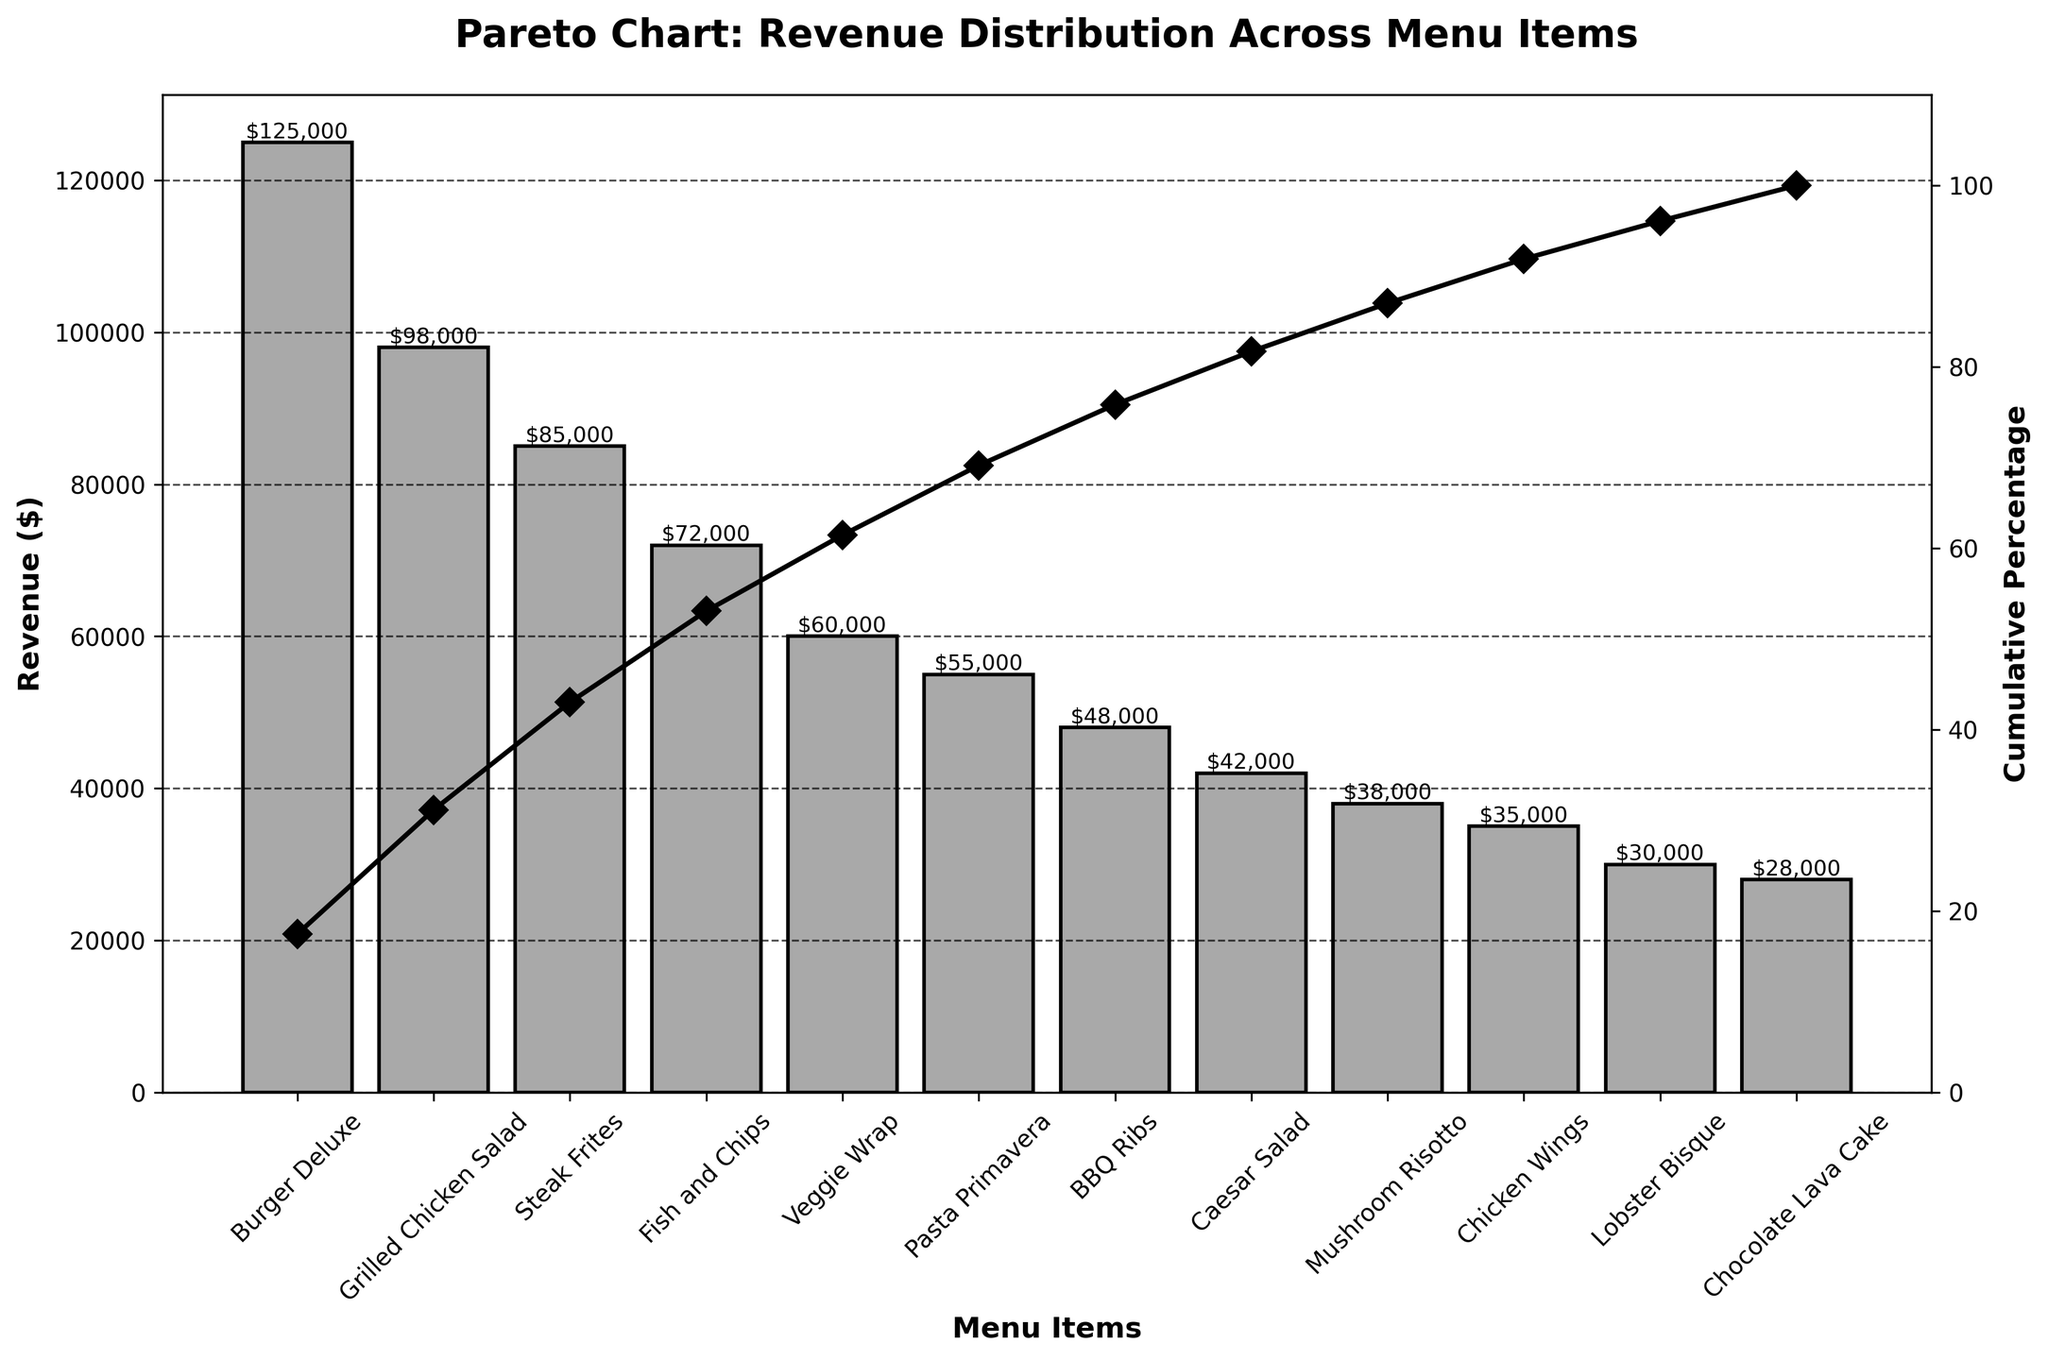Which menu item has the highest revenue? The bar representing the Burger Deluxe is the highest in the bar chart, indicating it generates the most revenue.
Answer: Burger Deluxe What is the total revenue of Burger Deluxe and Grilled Chicken Salad combined? The revenue for Burger Deluxe is $125,000, and for Grilled Chicken Salad, it is $98,000. Added together, they total $125,000 + $98,000 = $223,000.
Answer: $223,000 Which menu item is responsible for achieving the first 50% of cumulative revenue? By looking at the cumulative percentage line, we can see that Steak Frites helps achieve the first 50% of cumulative revenue, marking the halfway point on the graph.
Answer: Steak Frites What is the cumulative percentage after adding the revenue from Fish and Chips? The cumulative percentage after adding Fish and Chips is the sum of cumulative percentages of Burger Deluxe, Grilled Chicken Salad, Steak Frites, and Fish and Chips. This totals approximately 63%.
Answer: 63% How many menu items cumulatively contribute to at least 80% of the revenue? Starting from the highest revenue item to the lowest, we find the number of items contributing to 80% by following the cumulative percentage line. It reaches 80% around the sixth or seventh item. Hence, six menu items cumulatively contribute to at least 80%.
Answer: 6 Which generates more revenue: Veggie Wrap or Pasta Primavera? By comparing the heights of the bars for Veggie Wrap and Pasta Primavera, we can conclude that Veggie Wrap generates more revenue.
Answer: Veggie Wrap What is the approximate range of revenue values represented in the chart? The lowest revenue figure is that of Chocolate Lava Cake at $28,000, and the highest is Burger Deluxe at $125,000. Thus, the range is approximately $125,000 - $28,000 = $97,000.
Answer: $97,000 By how much does the revenue of BBQ Ribs differ from that of Caesar Salad? BBQ Ribs have a revenue of $48,000, and Caesar Salad has $42,000. The difference is $48,000 - $42,000 = $6,000.
Answer: $6,000 What percentage of revenue does the combination of Chicken Wings and Lobster Bisque contribute? Chicken Wings generate $35,000 and Lobster Bisque $30,000. Combined, they contribute $35,000 + $30,000 = $65,000. The total revenue figure is $722,000 (sum of all menu items' revenue). The percentage contribution is ($65,000 / $722,000) * 100 ≈ 9%.
Answer: 9% How does the revenue of Mushroom Risotto compare to Veggie Wrap? The revenue for Mushroom Risotto is $38,000, while for Veggie Wrap, it is $60,000. Mushroom Risotto makes $22,000 less in revenue compared to Veggie Wrap.
Answer: $22,000 less 